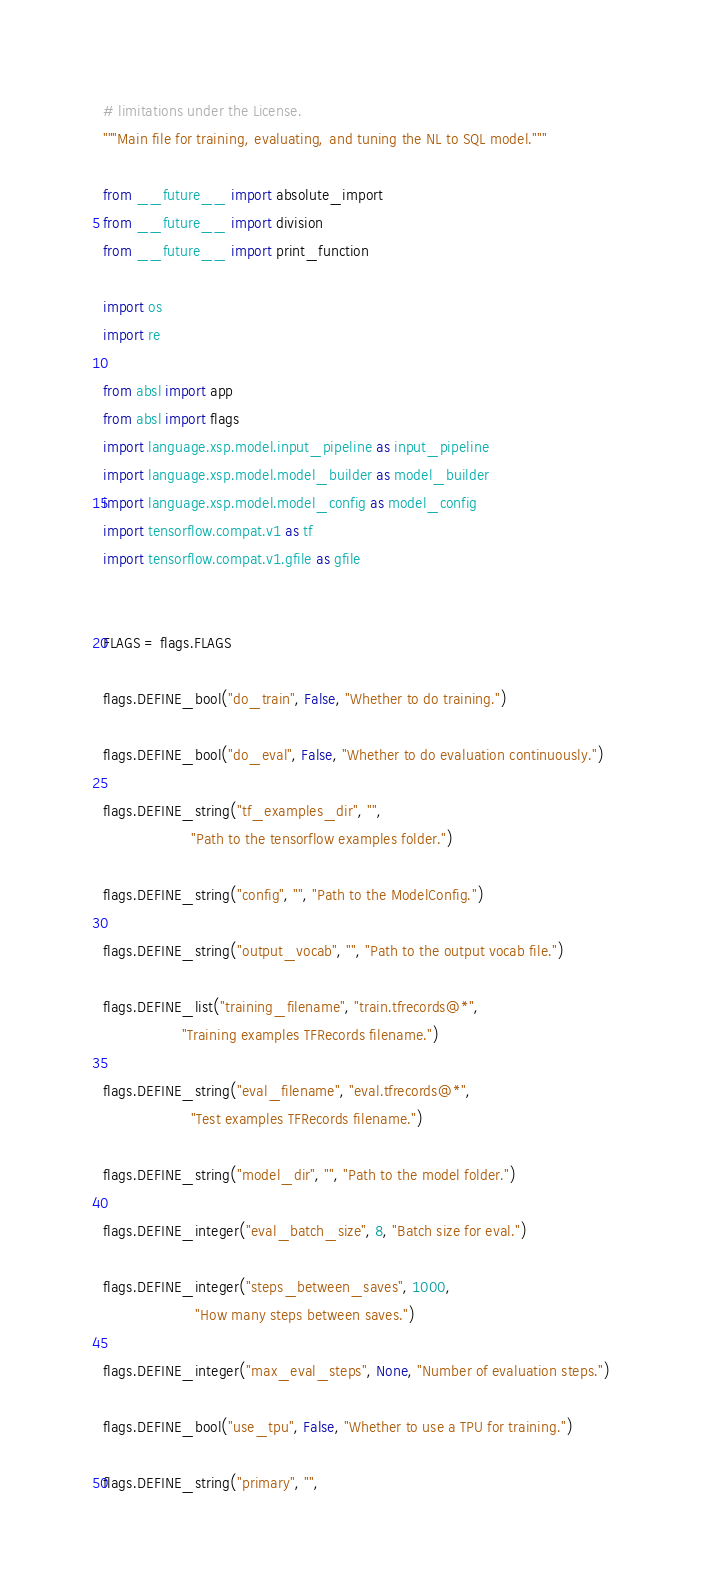<code> <loc_0><loc_0><loc_500><loc_500><_Python_># limitations under the License.
"""Main file for training, evaluating, and tuning the NL to SQL model."""

from __future__ import absolute_import
from __future__ import division
from __future__ import print_function

import os
import re

from absl import app
from absl import flags
import language.xsp.model.input_pipeline as input_pipeline
import language.xsp.model.model_builder as model_builder
import language.xsp.model.model_config as model_config
import tensorflow.compat.v1 as tf
import tensorflow.compat.v1.gfile as gfile


FLAGS = flags.FLAGS

flags.DEFINE_bool("do_train", False, "Whether to do training.")

flags.DEFINE_bool("do_eval", False, "Whether to do evaluation continuously.")

flags.DEFINE_string("tf_examples_dir", "",
                    "Path to the tensorflow examples folder.")

flags.DEFINE_string("config", "", "Path to the ModelConfig.")

flags.DEFINE_string("output_vocab", "", "Path to the output vocab file.")

flags.DEFINE_list("training_filename", "train.tfrecords@*",
                  "Training examples TFRecords filename.")

flags.DEFINE_string("eval_filename", "eval.tfrecords@*",
                    "Test examples TFRecords filename.")

flags.DEFINE_string("model_dir", "", "Path to the model folder.")

flags.DEFINE_integer("eval_batch_size", 8, "Batch size for eval.")

flags.DEFINE_integer("steps_between_saves", 1000,
                     "How many steps between saves.")

flags.DEFINE_integer("max_eval_steps", None, "Number of evaluation steps.")

flags.DEFINE_bool("use_tpu", False, "Whether to use a TPU for training.")

flags.DEFINE_string("primary", "",</code> 